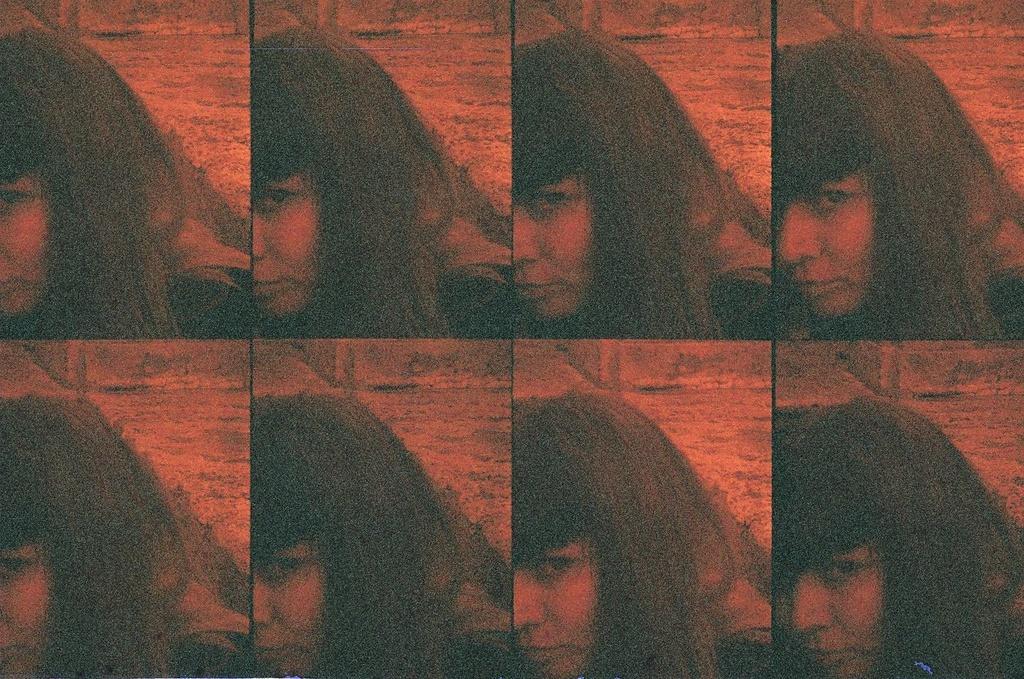Describe this image in one or two sentences. This is a collage image. In this picture we can see a lady. In the background of the image we can see the wall. 